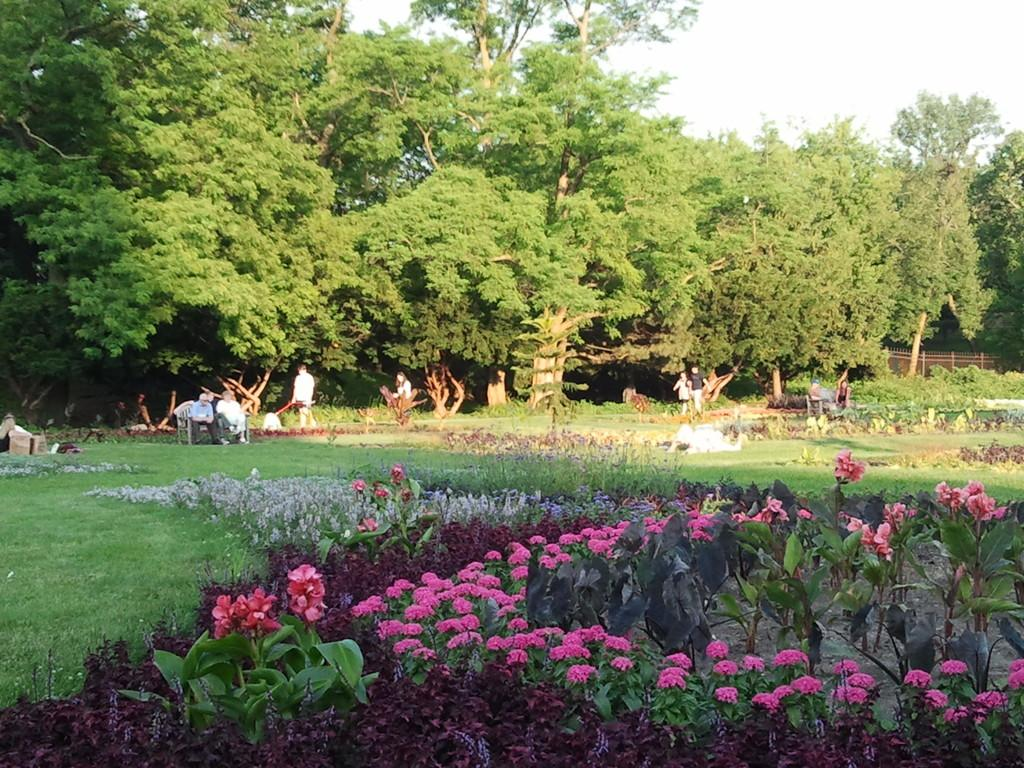What type of vegetation can be seen in the image? There are plants, flowers, and trees in the image. What can be found in the background of the image? There are trees in the background of the image. What else is present in the image besides vegetation? There are objects, a fence, and people in the image. What are some of the people in the image doing? Some people are sitting on chairs, and one person is holding an object. How many giants can be seen interacting with the cactus in the image? There are no giants or cactus present in the image. What type of cap is the person wearing in the image? There is no cap visible on any person in the image. 